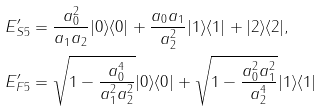Convert formula to latex. <formula><loc_0><loc_0><loc_500><loc_500>E ^ { \prime } _ { S 5 } & = \frac { a _ { 0 } ^ { 2 } } { a _ { 1 } a _ { 2 } } | 0 \rangle \langle 0 | + \frac { a _ { 0 } a _ { 1 } } { a _ { 2 } ^ { 2 } } | 1 \rangle \langle 1 | + | 2 \rangle \langle 2 | , \\ E ^ { \prime } _ { F 5 } & = \sqrt { 1 - \frac { a _ { 0 } ^ { 4 } } { a _ { 1 } ^ { 2 } a _ { 2 } ^ { 2 } } } | 0 \rangle \langle 0 | + \sqrt { 1 - \frac { a _ { 0 } ^ { 2 } a _ { 1 } ^ { 2 } } { a _ { 2 } ^ { 4 } } } | 1 \rangle \langle 1 |</formula> 